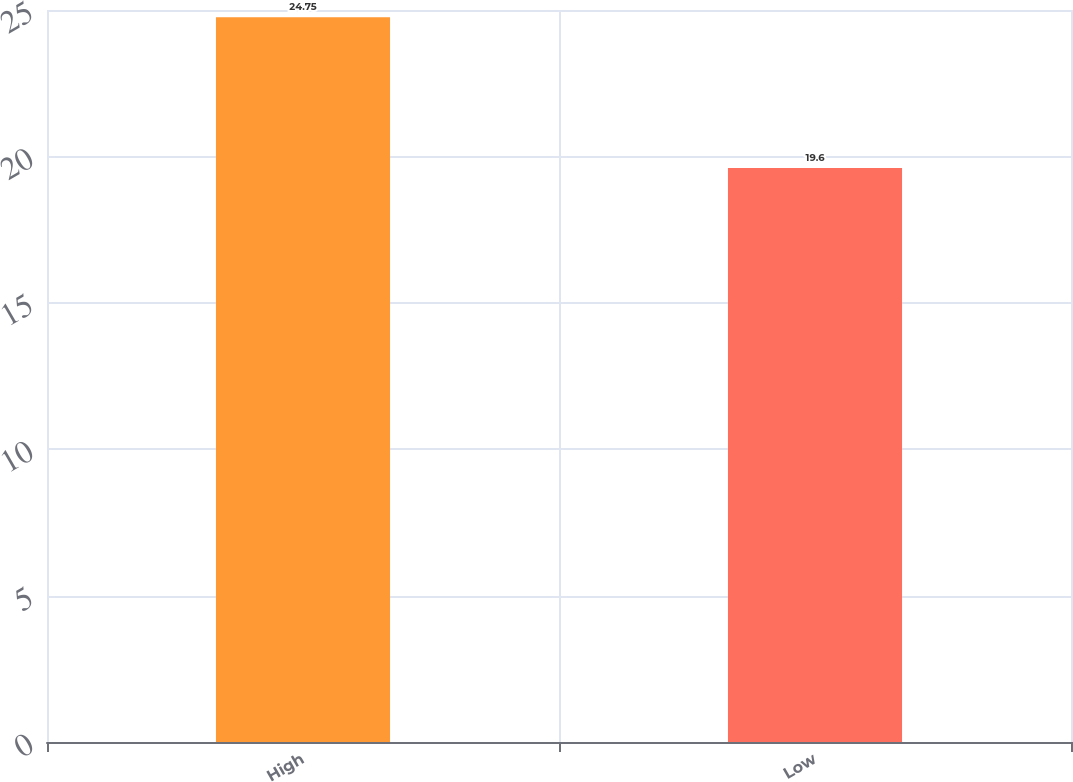Convert chart. <chart><loc_0><loc_0><loc_500><loc_500><bar_chart><fcel>High<fcel>Low<nl><fcel>24.75<fcel>19.6<nl></chart> 